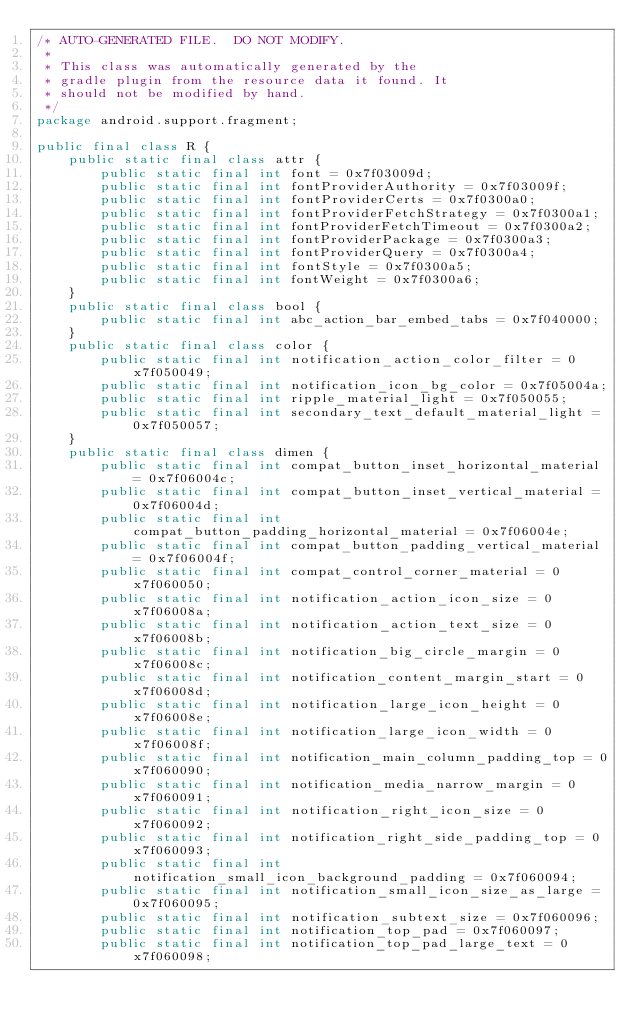Convert code to text. <code><loc_0><loc_0><loc_500><loc_500><_Java_>/* AUTO-GENERATED FILE.  DO NOT MODIFY.
 *
 * This class was automatically generated by the
 * gradle plugin from the resource data it found. It
 * should not be modified by hand.
 */
package android.support.fragment;

public final class R {
    public static final class attr {
        public static final int font = 0x7f03009d;
        public static final int fontProviderAuthority = 0x7f03009f;
        public static final int fontProviderCerts = 0x7f0300a0;
        public static final int fontProviderFetchStrategy = 0x7f0300a1;
        public static final int fontProviderFetchTimeout = 0x7f0300a2;
        public static final int fontProviderPackage = 0x7f0300a3;
        public static final int fontProviderQuery = 0x7f0300a4;
        public static final int fontStyle = 0x7f0300a5;
        public static final int fontWeight = 0x7f0300a6;
    }
    public static final class bool {
        public static final int abc_action_bar_embed_tabs = 0x7f040000;
    }
    public static final class color {
        public static final int notification_action_color_filter = 0x7f050049;
        public static final int notification_icon_bg_color = 0x7f05004a;
        public static final int ripple_material_light = 0x7f050055;
        public static final int secondary_text_default_material_light = 0x7f050057;
    }
    public static final class dimen {
        public static final int compat_button_inset_horizontal_material = 0x7f06004c;
        public static final int compat_button_inset_vertical_material = 0x7f06004d;
        public static final int compat_button_padding_horizontal_material = 0x7f06004e;
        public static final int compat_button_padding_vertical_material = 0x7f06004f;
        public static final int compat_control_corner_material = 0x7f060050;
        public static final int notification_action_icon_size = 0x7f06008a;
        public static final int notification_action_text_size = 0x7f06008b;
        public static final int notification_big_circle_margin = 0x7f06008c;
        public static final int notification_content_margin_start = 0x7f06008d;
        public static final int notification_large_icon_height = 0x7f06008e;
        public static final int notification_large_icon_width = 0x7f06008f;
        public static final int notification_main_column_padding_top = 0x7f060090;
        public static final int notification_media_narrow_margin = 0x7f060091;
        public static final int notification_right_icon_size = 0x7f060092;
        public static final int notification_right_side_padding_top = 0x7f060093;
        public static final int notification_small_icon_background_padding = 0x7f060094;
        public static final int notification_small_icon_size_as_large = 0x7f060095;
        public static final int notification_subtext_size = 0x7f060096;
        public static final int notification_top_pad = 0x7f060097;
        public static final int notification_top_pad_large_text = 0x7f060098;</code> 